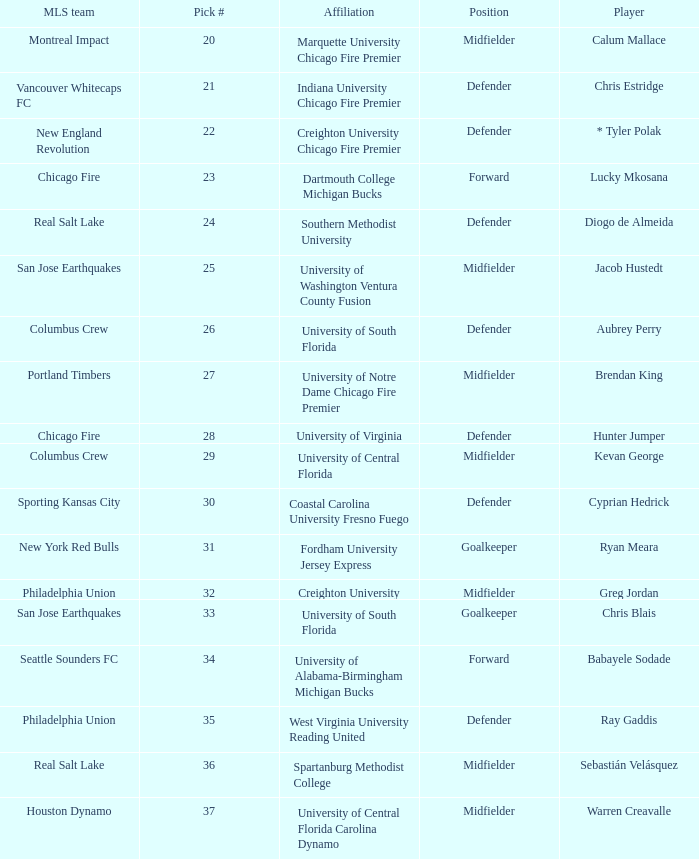Who was pick number 34? Babayele Sodade. 